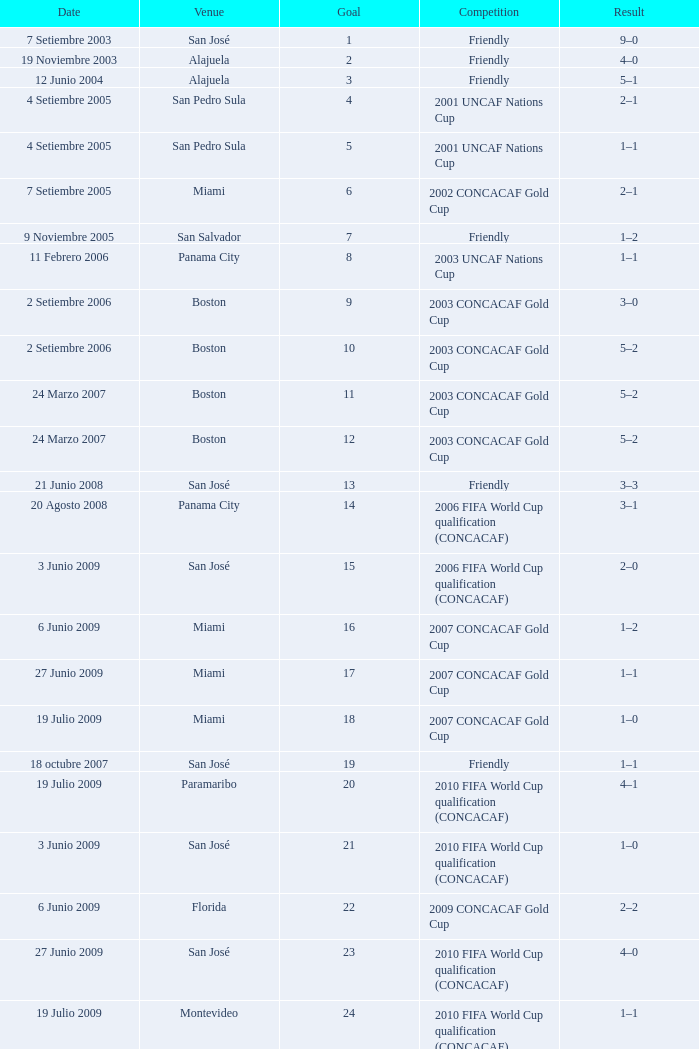At the venue of panama city, on 11 Febrero 2006, how many goals were scored? 1.0. 